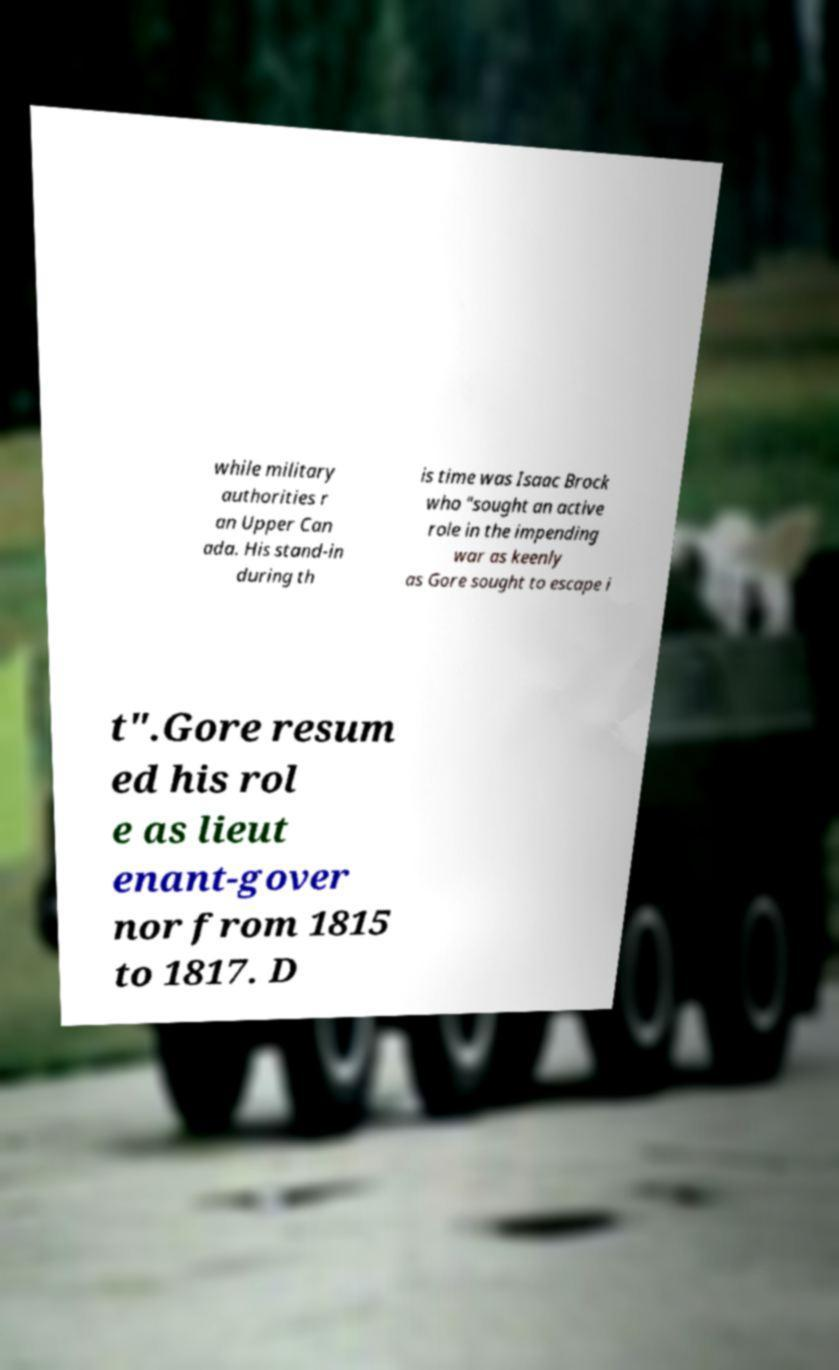What messages or text are displayed in this image? I need them in a readable, typed format. while military authorities r an Upper Can ada. His stand-in during th is time was Isaac Brock who "sought an active role in the impending war as keenly as Gore sought to escape i t".Gore resum ed his rol e as lieut enant-gover nor from 1815 to 1817. D 